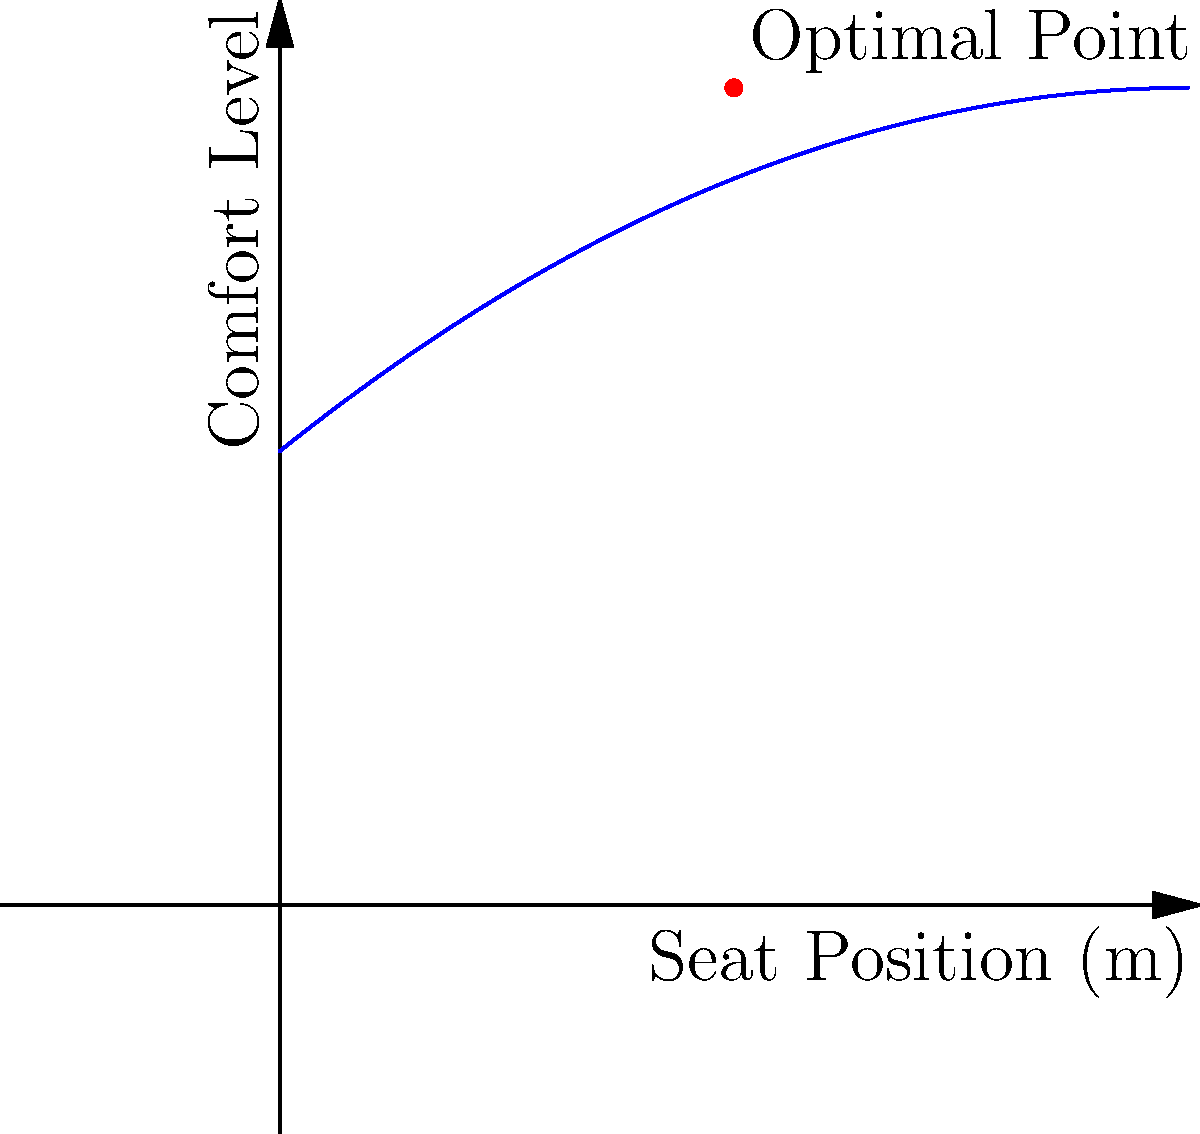In designing a luxurious cinema space, you're optimizing the seating arrangement based on a comfort function. The comfort level (y) in relation to the seat position (x) from the screen is modeled by the polynomial function: $$y = -0.02x^2 + 0.8x + 10$$, where x is measured in meters. What is the optimal seat position for maximum comfort, and what is the maximum comfort level achieved? To find the optimal seat position and maximum comfort level, we need to follow these steps:

1. The given function is a quadratic polynomial: $$y = -0.02x^2 + 0.8x + 10$$

2. For a quadratic function in the form $$f(x) = ax^2 + bx + c$$, the x-coordinate of the vertex (optimal point) is given by $$x = -\frac{b}{2a}$$

3. In this case, $a = -0.02$ and $b = 0.8$. Let's substitute these values:

   $$x = -\frac{0.8}{2(-0.02)} = -\frac{0.8}{-0.04} = 20$$

4. To find the maximum comfort level, we substitute this x-value back into the original equation:

   $$y = -0.02(20)^2 + 0.8(20) + 10$$
   $$y = -0.02(400) + 16 + 10$$
   $$y = -8 + 16 + 10 = 18$$

5. Therefore, the optimal seat position is 20 meters from the screen, and the maximum comfort level achieved is 18.
Answer: Optimal seat position: 20 m; Maximum comfort level: 18 